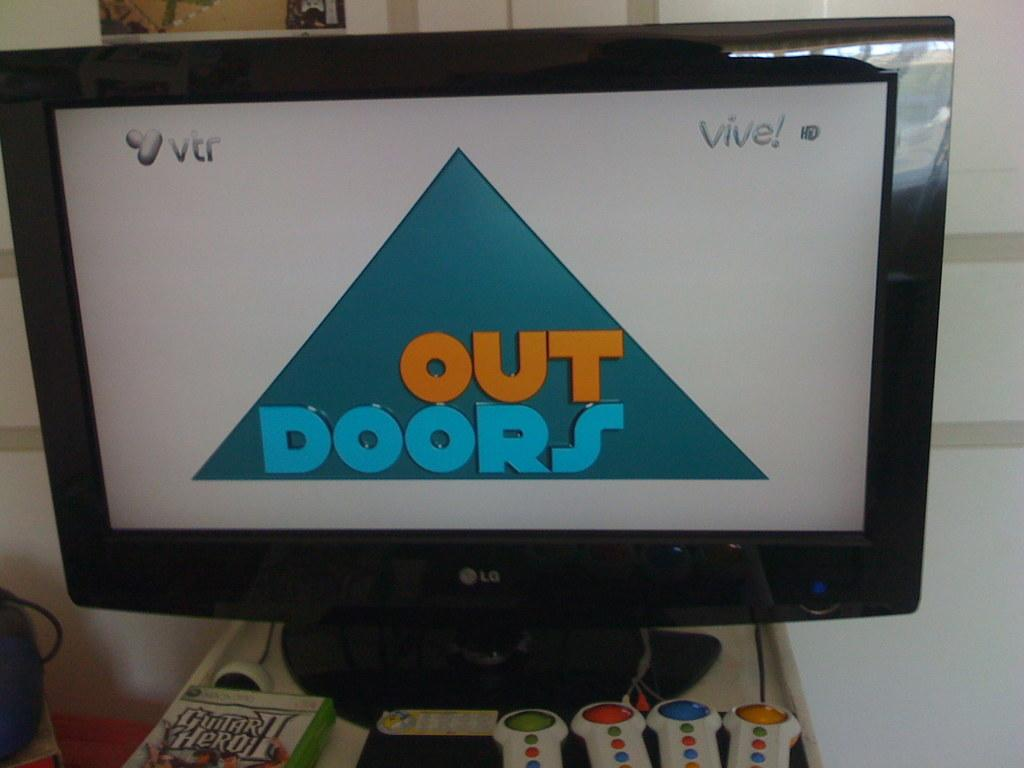<image>
Relay a brief, clear account of the picture shown. LG TV showing Out Doors on the screen with an xbox copy of guitar hero 2 just below the tv. 